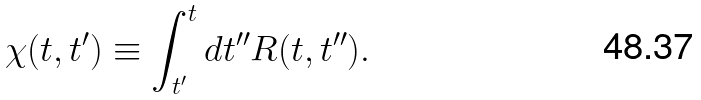Convert formula to latex. <formula><loc_0><loc_0><loc_500><loc_500>\chi ( t , t ^ { \prime } ) \equiv \int _ { t ^ { \prime } } ^ { t } d t ^ { \prime \prime } R ( t , t ^ { \prime \prime } ) .</formula> 